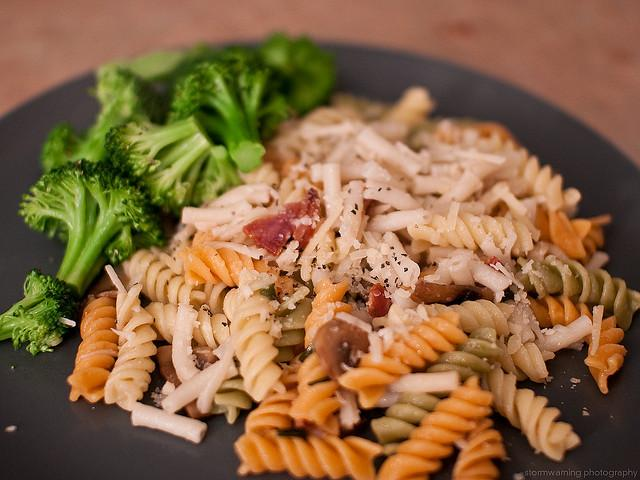What is next to the pasta?

Choices:
A) apple
B) beef
C) lemon
D) broccoli broccoli 